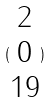Convert formula to latex. <formula><loc_0><loc_0><loc_500><loc_500>( \begin{matrix} 2 \\ 0 \\ 1 9 \end{matrix} )</formula> 